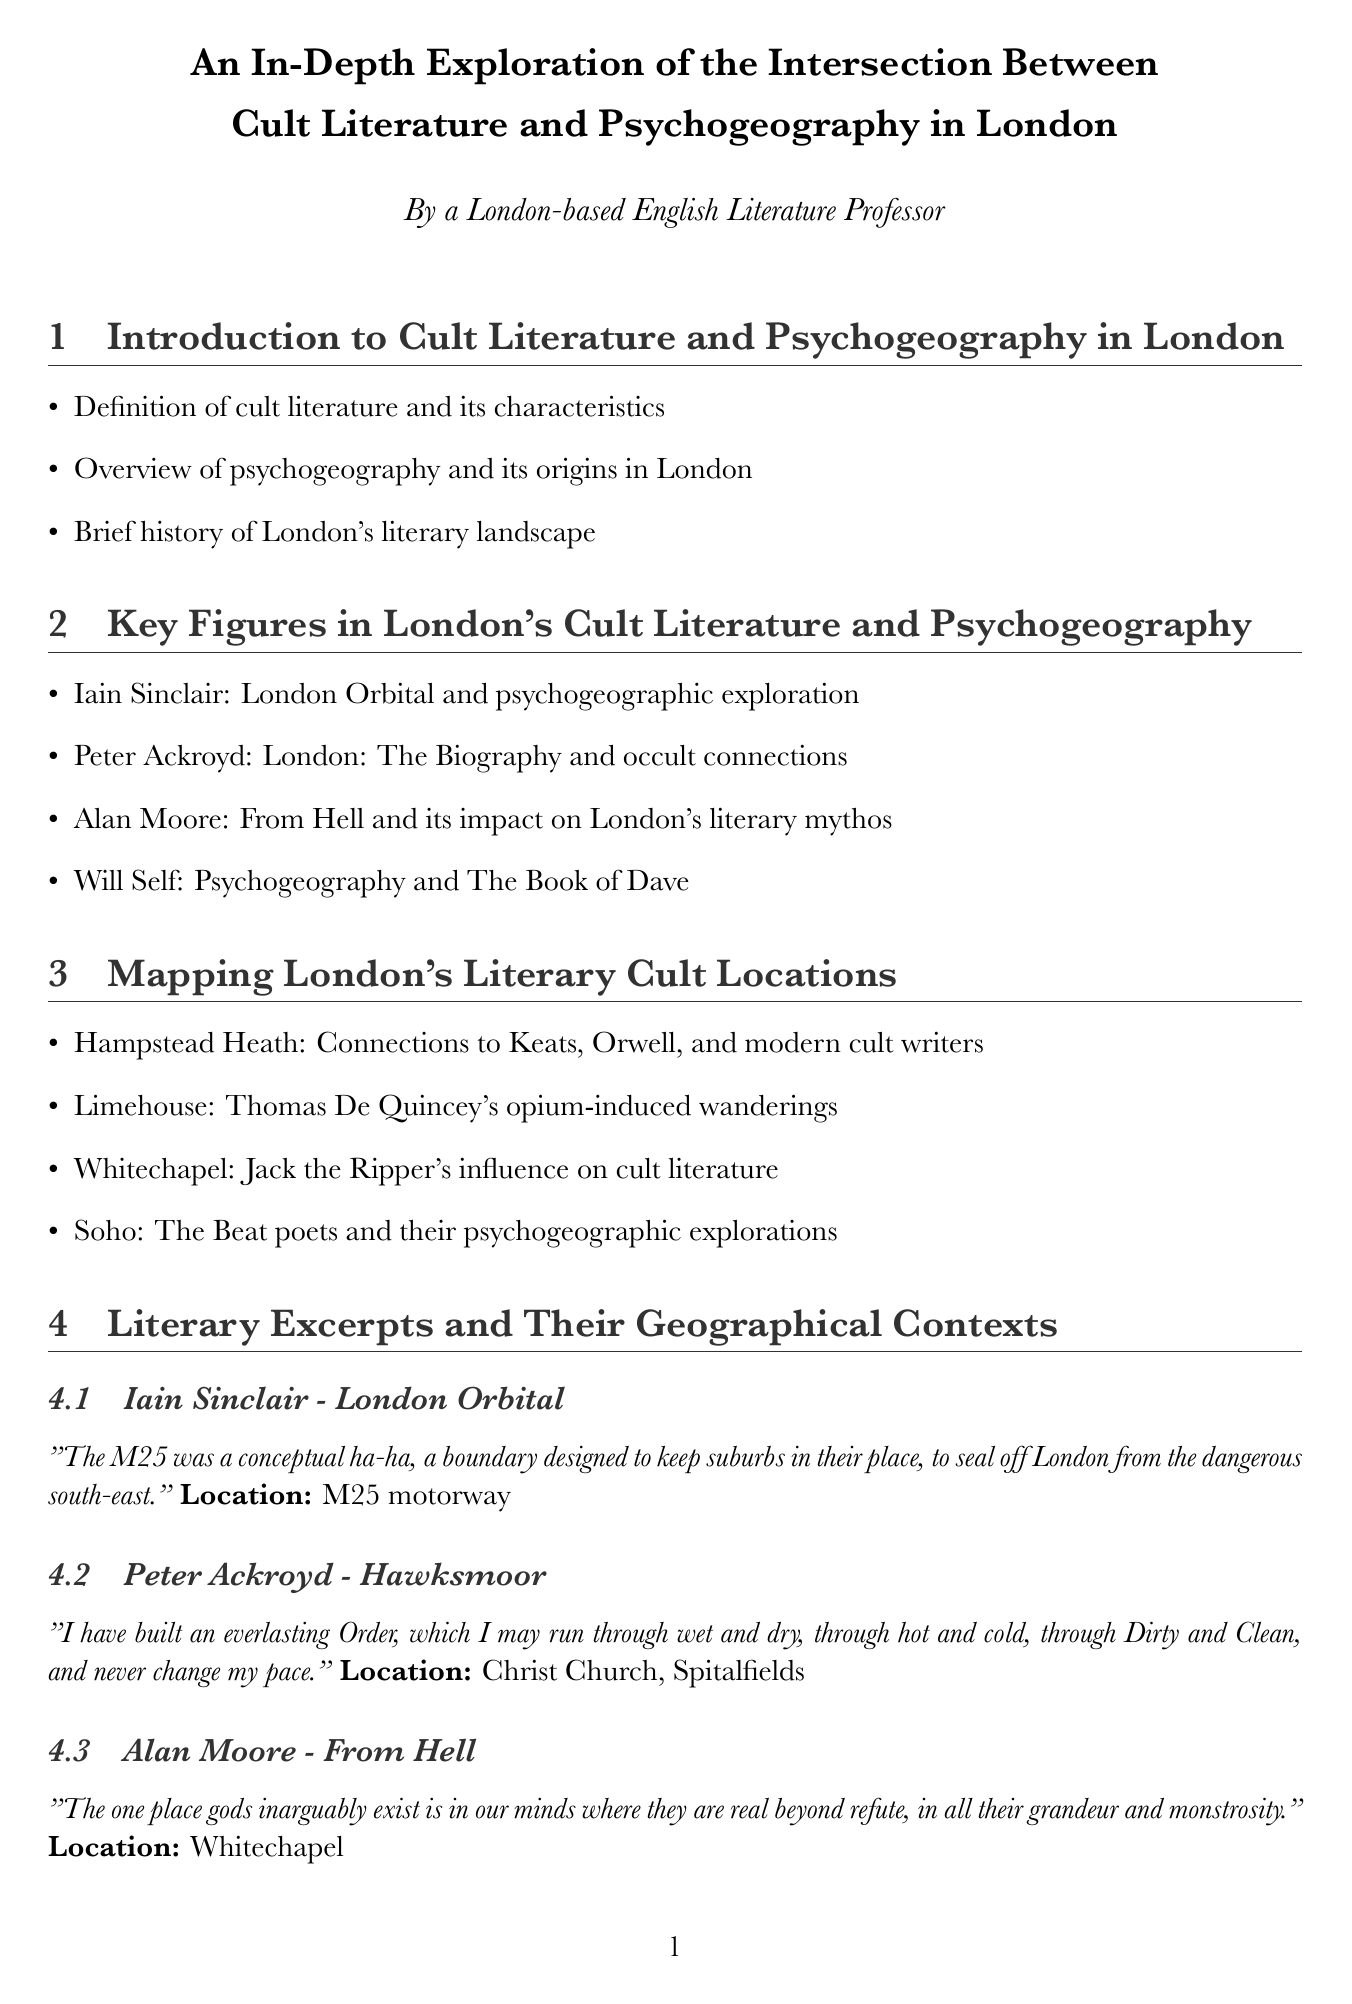What is the title of the report? The title is stated at the beginning of the document as the main heading.
Answer: An In-Depth Exploration of the Intersection Between Cult Literature and Psychogeography in London Who is a key figure mentioned in relation to psychogeography? The section on key figures lists several names, with Iain Sinclair prominently mentioned.
Answer: Iain Sinclair What is one technique discussed in psychogeographic literature? The document details specific techniques used in the context of psychogeography.
Answer: Dérive Which literary work features the location Whitechapel? The literary excerpts section specifies which excerpts correspond to certain locations, including this one.
Answer: From Hell What year range does the report focus on in relation to London's literary landscape? The introduction provides an overview of London's literary landscape, but the specific dates might not be mentioned in detail.
Answer: Not specified Which map title refers to Peter Ackroyd's works? The maps section includes specific titles that refer to locations related to particular authors.
Answer: Occult London: Sites from Peter Ackroyd's Works What is the primary focus of the report's conclusion? The conclusion discusses overarching themes and future implications based on earlier sections.
Answer: The Future of Cult Literature and Psychogeography in London What geographic boundary is mentioned in the context of psychogeography? The report discusses specific themes and concepts relevant to urban landscapes, including this boundary.
Answer: The Thames 